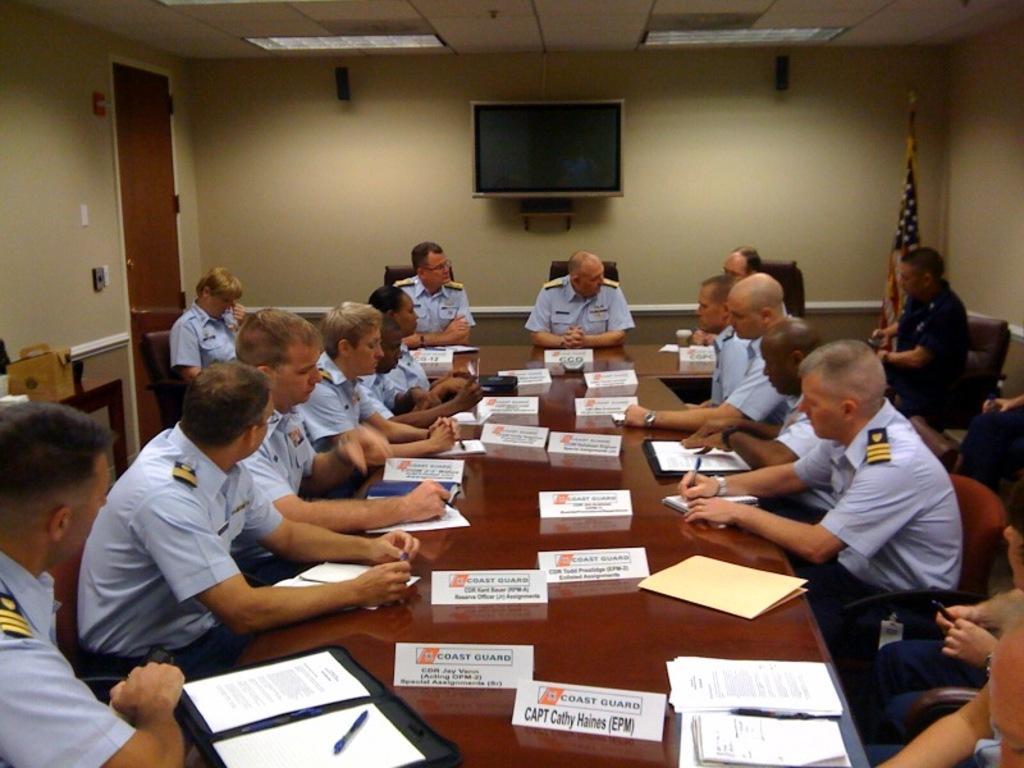How would you summarize this image in a sentence or two? There are persons sitting on chairs around a table, on which, there are name boards and files arranged. In the background, there is a monitor on the wall, there are lights attached to the roof, there is a door and other objects. 